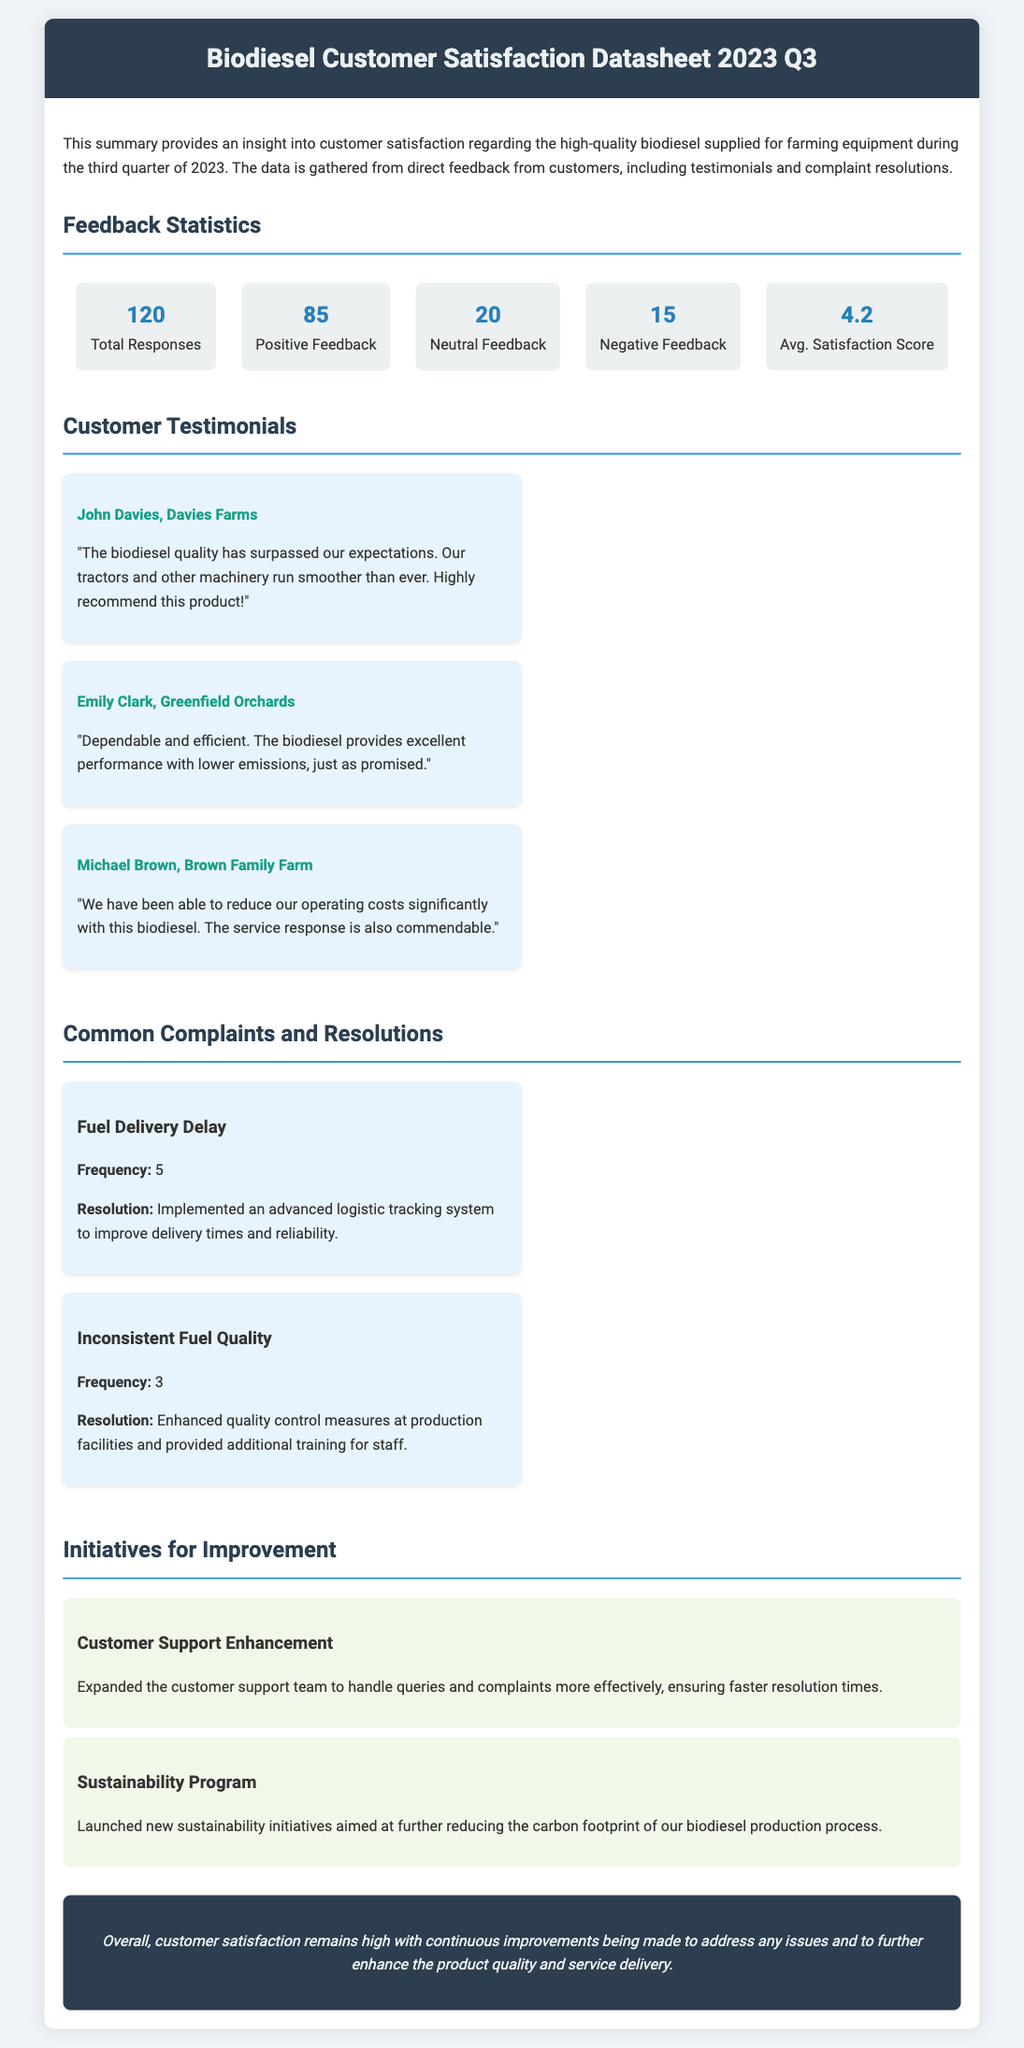What is the total number of responses? The total number of responses is indicated in the feedback statistics section of the document.
Answer: 120 How many customers provided positive feedback? The document states that 85 customers provided positive feedback according to the feedback statistics.
Answer: 85 What is the average satisfaction score? The average satisfaction score is highlighted in the feedback statistics section.
Answer: 4.2 Who is the customer that praised the quality of biodiesel? The testimonial section features John Davies from Davies Farms who praised the biodiesel quality.
Answer: John Davies What initiative was launched to improve sustainability? The document notes a new initiative focused on sustainability efforts in biodiesel production.
Answer: Sustainability Program How many complaints were related to fuel delivery delays? The common complaints section indicates that there were 5 complaints about fuel delivery delays.
Answer: 5 What was implemented to improve delivery times? The resolution to address fuel delivery delays involved implementing an advanced logistic tracking system.
Answer: Advanced logistic tracking system Which customer noted a reduction in operating costs? Michael Brown from Brown Family Farm noted a reduction in operating costs in his testimonial.
Answer: Michael Brown What frequency was noted for inconsistent fuel quality complaints? The document specifies a frequency of 3 complaints related to inconsistent fuel quality.
Answer: 3 